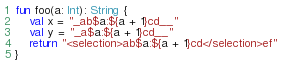<code> <loc_0><loc_0><loc_500><loc_500><_Kotlin_>fun foo(a: Int): String {
    val x = "_ab$a:${a + 1}cd__"
    val y = "_a$a:${a + 1}cd__"
    return "<selection>ab$a:${a + 1}cd</selection>ef"
}</code> 